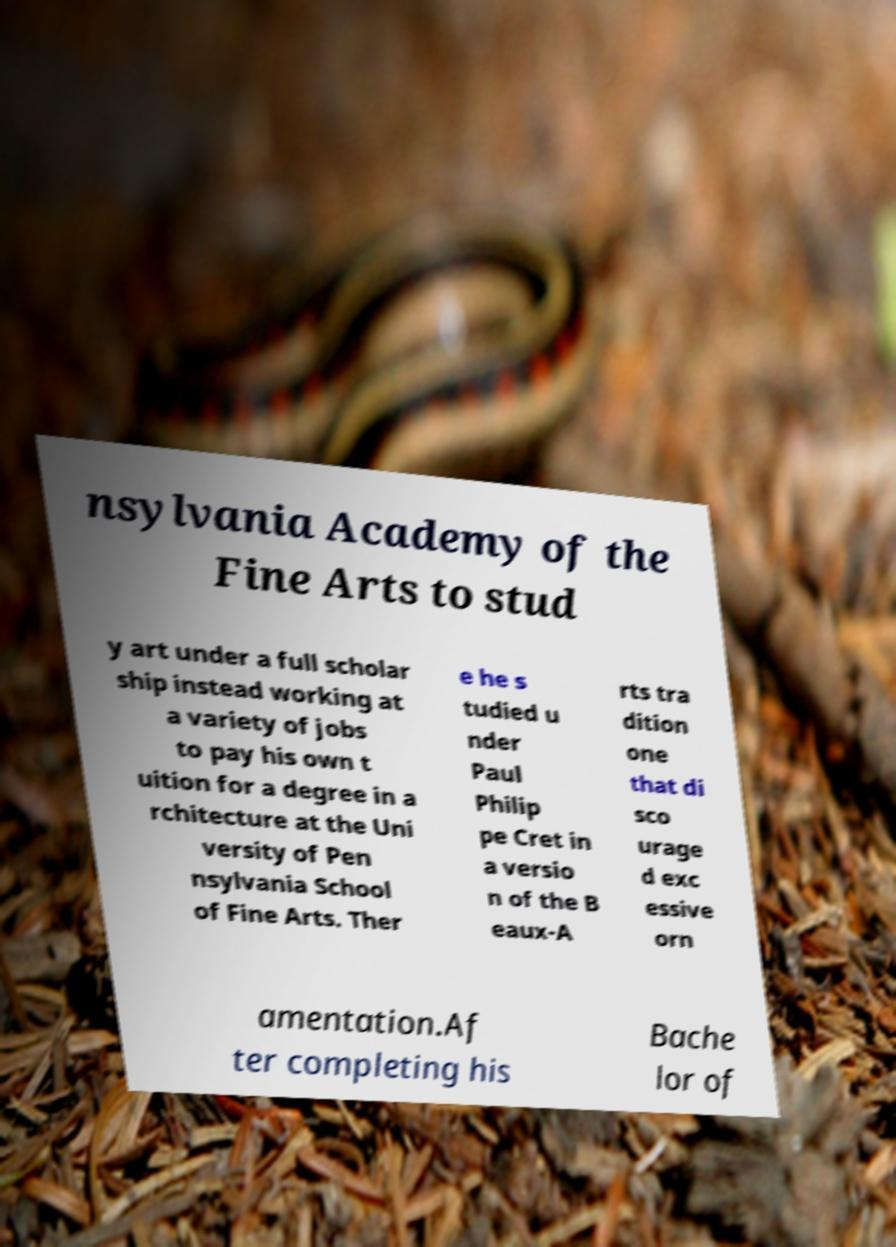For documentation purposes, I need the text within this image transcribed. Could you provide that? nsylvania Academy of the Fine Arts to stud y art under a full scholar ship instead working at a variety of jobs to pay his own t uition for a degree in a rchitecture at the Uni versity of Pen nsylvania School of Fine Arts. Ther e he s tudied u nder Paul Philip pe Cret in a versio n of the B eaux-A rts tra dition one that di sco urage d exc essive orn amentation.Af ter completing his Bache lor of 